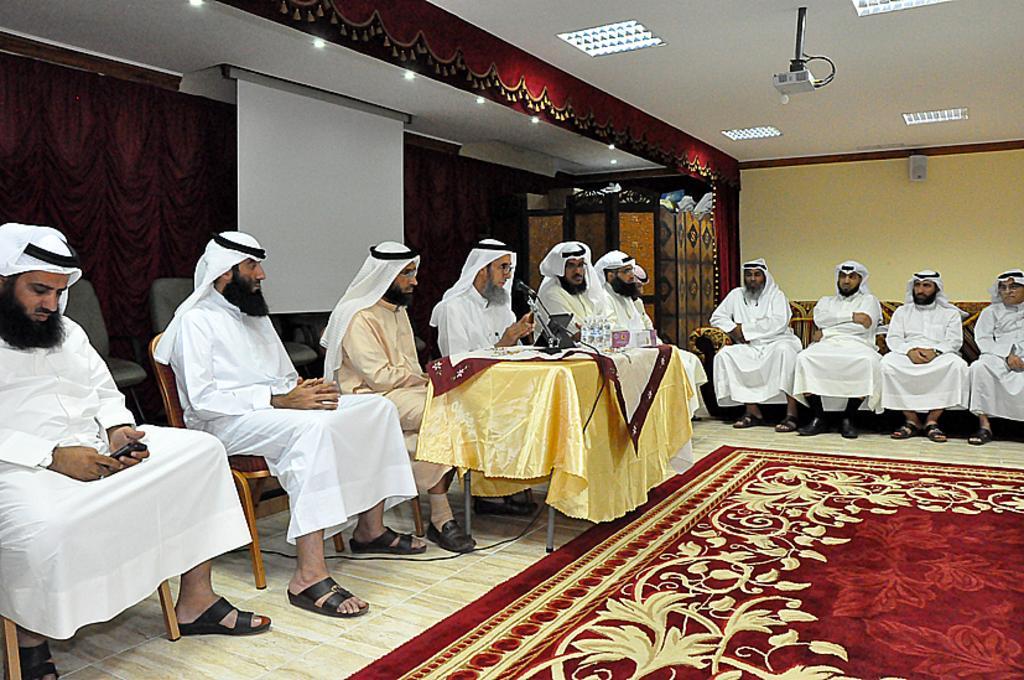Could you give a brief overview of what you see in this image? In this image few persons wearing a white shirt are siting on the chairs. There is a table having a mike and few bottles are on it. Left side there is curtain. Before it there is a display screen hangs from the roof. There are few lights and projector are attached to the roof. Bottom of image there is a carpet. 